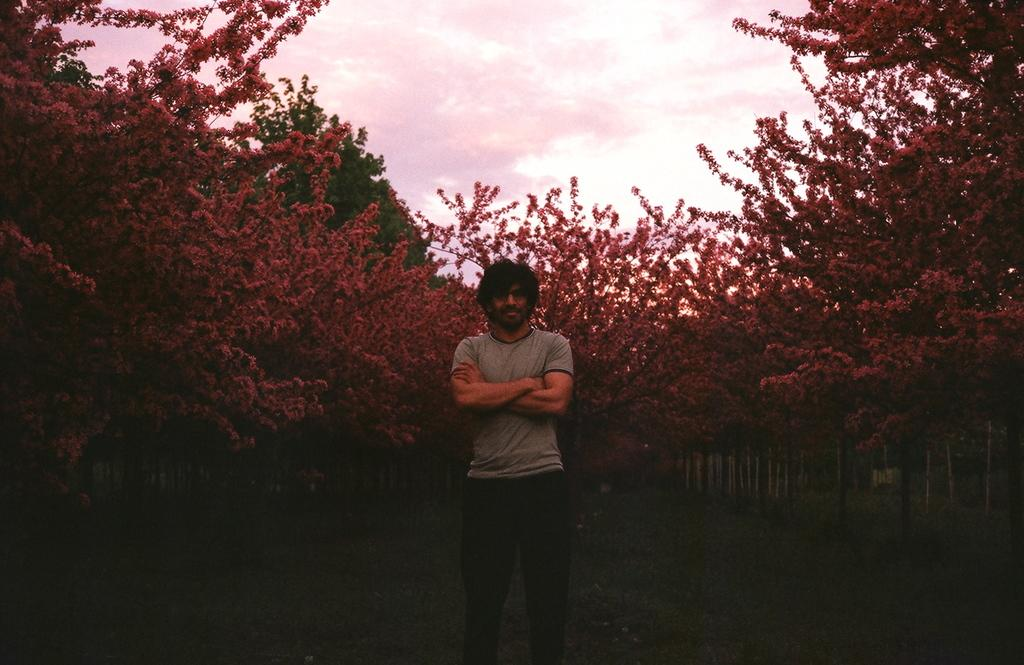What is the main subject of the image? There is a man in the image. What is the man doing with his hand? The man is holding his hand. What can be seen in the background of the image? There are red trees visible behind the man. What is the man's reaction to the surprise in the image? There is no surprise present in the image, so it is not possible to determine the man's reaction. 